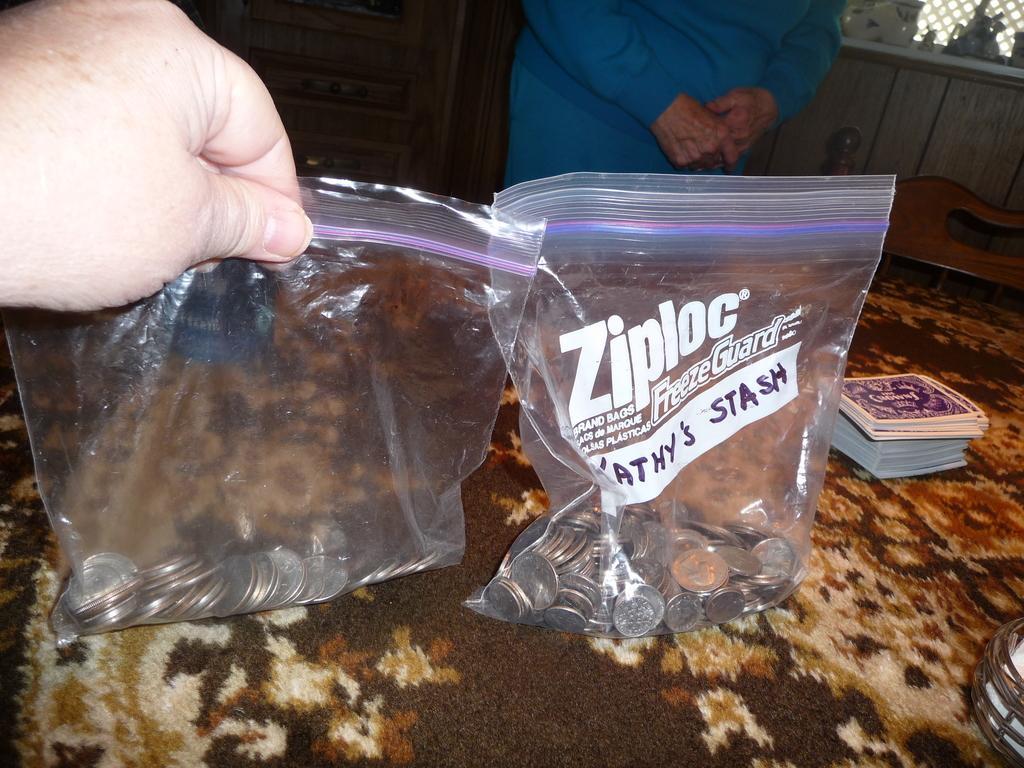Could you give a brief overview of what you see in this image? In this image there are coins in covers, there are cards and an item on the table, a person holding a cover of coins, and in the background there is a chair and a person standing. 